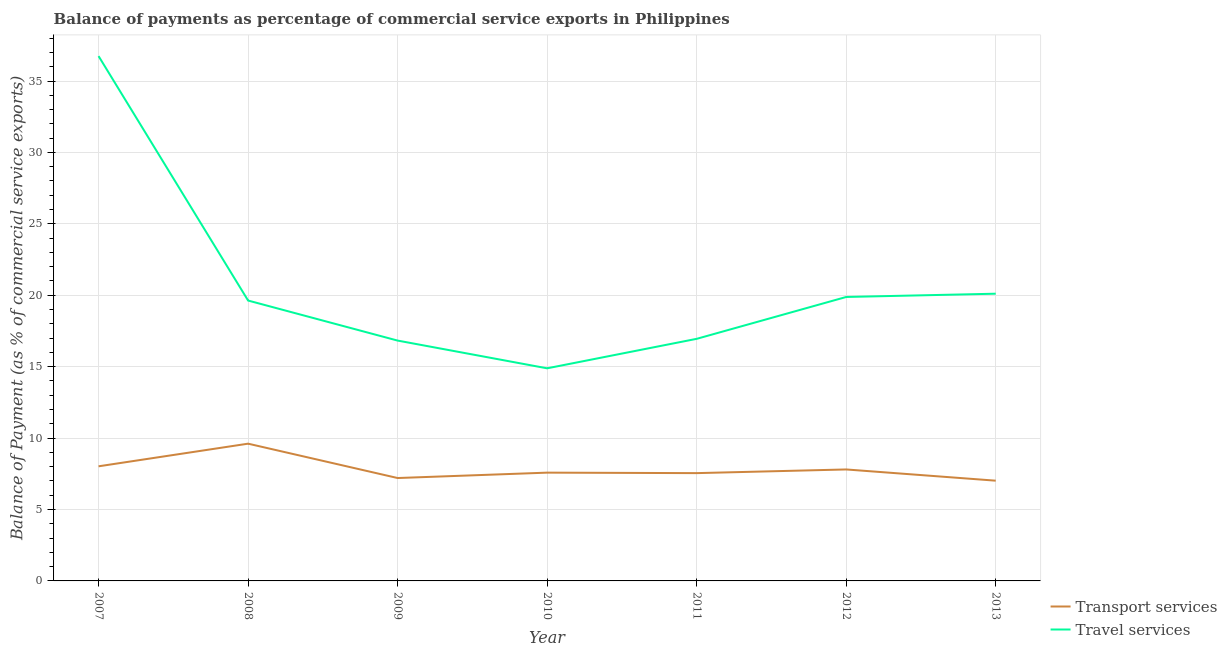How many different coloured lines are there?
Provide a short and direct response. 2. Is the number of lines equal to the number of legend labels?
Ensure brevity in your answer.  Yes. What is the balance of payments of transport services in 2011?
Make the answer very short. 7.55. Across all years, what is the maximum balance of payments of travel services?
Your response must be concise. 36.74. Across all years, what is the minimum balance of payments of travel services?
Give a very brief answer. 14.88. In which year was the balance of payments of transport services maximum?
Provide a short and direct response. 2008. What is the total balance of payments of transport services in the graph?
Your response must be concise. 54.79. What is the difference between the balance of payments of transport services in 2008 and that in 2011?
Provide a short and direct response. 2.06. What is the difference between the balance of payments of transport services in 2012 and the balance of payments of travel services in 2010?
Provide a succinct answer. -7.08. What is the average balance of payments of transport services per year?
Provide a short and direct response. 7.83. In the year 2010, what is the difference between the balance of payments of travel services and balance of payments of transport services?
Make the answer very short. 7.3. In how many years, is the balance of payments of travel services greater than 6 %?
Your response must be concise. 7. What is the ratio of the balance of payments of travel services in 2007 to that in 2010?
Offer a terse response. 2.47. Is the balance of payments of travel services in 2007 less than that in 2012?
Ensure brevity in your answer.  No. Is the difference between the balance of payments of transport services in 2009 and 2010 greater than the difference between the balance of payments of travel services in 2009 and 2010?
Your answer should be very brief. No. What is the difference between the highest and the second highest balance of payments of travel services?
Ensure brevity in your answer.  16.63. What is the difference between the highest and the lowest balance of payments of travel services?
Make the answer very short. 21.86. Is the balance of payments of travel services strictly less than the balance of payments of transport services over the years?
Provide a short and direct response. No. How many lines are there?
Your response must be concise. 2. How many years are there in the graph?
Make the answer very short. 7. Does the graph contain any zero values?
Keep it short and to the point. No. How are the legend labels stacked?
Make the answer very short. Vertical. What is the title of the graph?
Make the answer very short. Balance of payments as percentage of commercial service exports in Philippines. Does "Urban Population" appear as one of the legend labels in the graph?
Make the answer very short. No. What is the label or title of the Y-axis?
Make the answer very short. Balance of Payment (as % of commercial service exports). What is the Balance of Payment (as % of commercial service exports) in Transport services in 2007?
Offer a terse response. 8.02. What is the Balance of Payment (as % of commercial service exports) in Travel services in 2007?
Provide a short and direct response. 36.74. What is the Balance of Payment (as % of commercial service exports) in Transport services in 2008?
Keep it short and to the point. 9.61. What is the Balance of Payment (as % of commercial service exports) in Travel services in 2008?
Your response must be concise. 19.63. What is the Balance of Payment (as % of commercial service exports) of Transport services in 2009?
Provide a short and direct response. 7.2. What is the Balance of Payment (as % of commercial service exports) in Travel services in 2009?
Your answer should be very brief. 16.83. What is the Balance of Payment (as % of commercial service exports) of Transport services in 2010?
Your answer should be very brief. 7.58. What is the Balance of Payment (as % of commercial service exports) in Travel services in 2010?
Provide a short and direct response. 14.88. What is the Balance of Payment (as % of commercial service exports) of Transport services in 2011?
Offer a very short reply. 7.55. What is the Balance of Payment (as % of commercial service exports) in Travel services in 2011?
Provide a succinct answer. 16.95. What is the Balance of Payment (as % of commercial service exports) of Transport services in 2012?
Make the answer very short. 7.8. What is the Balance of Payment (as % of commercial service exports) in Travel services in 2012?
Provide a short and direct response. 19.88. What is the Balance of Payment (as % of commercial service exports) of Transport services in 2013?
Make the answer very short. 7.02. What is the Balance of Payment (as % of commercial service exports) in Travel services in 2013?
Your response must be concise. 20.11. Across all years, what is the maximum Balance of Payment (as % of commercial service exports) in Transport services?
Your response must be concise. 9.61. Across all years, what is the maximum Balance of Payment (as % of commercial service exports) of Travel services?
Give a very brief answer. 36.74. Across all years, what is the minimum Balance of Payment (as % of commercial service exports) in Transport services?
Offer a very short reply. 7.02. Across all years, what is the minimum Balance of Payment (as % of commercial service exports) in Travel services?
Ensure brevity in your answer.  14.88. What is the total Balance of Payment (as % of commercial service exports) in Transport services in the graph?
Offer a very short reply. 54.79. What is the total Balance of Payment (as % of commercial service exports) in Travel services in the graph?
Your answer should be very brief. 145.02. What is the difference between the Balance of Payment (as % of commercial service exports) in Transport services in 2007 and that in 2008?
Keep it short and to the point. -1.58. What is the difference between the Balance of Payment (as % of commercial service exports) of Travel services in 2007 and that in 2008?
Provide a short and direct response. 17.11. What is the difference between the Balance of Payment (as % of commercial service exports) in Transport services in 2007 and that in 2009?
Offer a very short reply. 0.82. What is the difference between the Balance of Payment (as % of commercial service exports) of Travel services in 2007 and that in 2009?
Give a very brief answer. 19.92. What is the difference between the Balance of Payment (as % of commercial service exports) in Transport services in 2007 and that in 2010?
Provide a succinct answer. 0.44. What is the difference between the Balance of Payment (as % of commercial service exports) of Travel services in 2007 and that in 2010?
Offer a very short reply. 21.86. What is the difference between the Balance of Payment (as % of commercial service exports) in Transport services in 2007 and that in 2011?
Keep it short and to the point. 0.48. What is the difference between the Balance of Payment (as % of commercial service exports) of Travel services in 2007 and that in 2011?
Offer a terse response. 19.79. What is the difference between the Balance of Payment (as % of commercial service exports) in Transport services in 2007 and that in 2012?
Keep it short and to the point. 0.22. What is the difference between the Balance of Payment (as % of commercial service exports) of Travel services in 2007 and that in 2012?
Ensure brevity in your answer.  16.86. What is the difference between the Balance of Payment (as % of commercial service exports) of Transport services in 2007 and that in 2013?
Offer a terse response. 1.01. What is the difference between the Balance of Payment (as % of commercial service exports) of Travel services in 2007 and that in 2013?
Your answer should be compact. 16.63. What is the difference between the Balance of Payment (as % of commercial service exports) of Transport services in 2008 and that in 2009?
Your answer should be very brief. 2.41. What is the difference between the Balance of Payment (as % of commercial service exports) in Travel services in 2008 and that in 2009?
Make the answer very short. 2.8. What is the difference between the Balance of Payment (as % of commercial service exports) of Transport services in 2008 and that in 2010?
Make the answer very short. 2.03. What is the difference between the Balance of Payment (as % of commercial service exports) of Travel services in 2008 and that in 2010?
Keep it short and to the point. 4.74. What is the difference between the Balance of Payment (as % of commercial service exports) of Transport services in 2008 and that in 2011?
Keep it short and to the point. 2.06. What is the difference between the Balance of Payment (as % of commercial service exports) in Travel services in 2008 and that in 2011?
Your answer should be compact. 2.68. What is the difference between the Balance of Payment (as % of commercial service exports) of Transport services in 2008 and that in 2012?
Your response must be concise. 1.81. What is the difference between the Balance of Payment (as % of commercial service exports) in Travel services in 2008 and that in 2012?
Your response must be concise. -0.25. What is the difference between the Balance of Payment (as % of commercial service exports) of Transport services in 2008 and that in 2013?
Your answer should be compact. 2.59. What is the difference between the Balance of Payment (as % of commercial service exports) in Travel services in 2008 and that in 2013?
Provide a succinct answer. -0.48. What is the difference between the Balance of Payment (as % of commercial service exports) of Transport services in 2009 and that in 2010?
Provide a succinct answer. -0.38. What is the difference between the Balance of Payment (as % of commercial service exports) of Travel services in 2009 and that in 2010?
Give a very brief answer. 1.94. What is the difference between the Balance of Payment (as % of commercial service exports) in Transport services in 2009 and that in 2011?
Keep it short and to the point. -0.34. What is the difference between the Balance of Payment (as % of commercial service exports) in Travel services in 2009 and that in 2011?
Keep it short and to the point. -0.12. What is the difference between the Balance of Payment (as % of commercial service exports) in Transport services in 2009 and that in 2012?
Give a very brief answer. -0.6. What is the difference between the Balance of Payment (as % of commercial service exports) in Travel services in 2009 and that in 2012?
Keep it short and to the point. -3.05. What is the difference between the Balance of Payment (as % of commercial service exports) in Transport services in 2009 and that in 2013?
Your response must be concise. 0.19. What is the difference between the Balance of Payment (as % of commercial service exports) of Travel services in 2009 and that in 2013?
Your answer should be very brief. -3.28. What is the difference between the Balance of Payment (as % of commercial service exports) of Transport services in 2010 and that in 2011?
Your response must be concise. 0.03. What is the difference between the Balance of Payment (as % of commercial service exports) in Travel services in 2010 and that in 2011?
Give a very brief answer. -2.06. What is the difference between the Balance of Payment (as % of commercial service exports) of Transport services in 2010 and that in 2012?
Keep it short and to the point. -0.22. What is the difference between the Balance of Payment (as % of commercial service exports) of Travel services in 2010 and that in 2012?
Your response must be concise. -4.99. What is the difference between the Balance of Payment (as % of commercial service exports) in Transport services in 2010 and that in 2013?
Your answer should be very brief. 0.56. What is the difference between the Balance of Payment (as % of commercial service exports) of Travel services in 2010 and that in 2013?
Provide a succinct answer. -5.22. What is the difference between the Balance of Payment (as % of commercial service exports) in Transport services in 2011 and that in 2012?
Give a very brief answer. -0.26. What is the difference between the Balance of Payment (as % of commercial service exports) of Travel services in 2011 and that in 2012?
Your response must be concise. -2.93. What is the difference between the Balance of Payment (as % of commercial service exports) of Transport services in 2011 and that in 2013?
Offer a very short reply. 0.53. What is the difference between the Balance of Payment (as % of commercial service exports) of Travel services in 2011 and that in 2013?
Your answer should be very brief. -3.16. What is the difference between the Balance of Payment (as % of commercial service exports) of Transport services in 2012 and that in 2013?
Your answer should be very brief. 0.79. What is the difference between the Balance of Payment (as % of commercial service exports) in Travel services in 2012 and that in 2013?
Your response must be concise. -0.23. What is the difference between the Balance of Payment (as % of commercial service exports) in Transport services in 2007 and the Balance of Payment (as % of commercial service exports) in Travel services in 2008?
Provide a short and direct response. -11.61. What is the difference between the Balance of Payment (as % of commercial service exports) in Transport services in 2007 and the Balance of Payment (as % of commercial service exports) in Travel services in 2009?
Your answer should be compact. -8.8. What is the difference between the Balance of Payment (as % of commercial service exports) in Transport services in 2007 and the Balance of Payment (as % of commercial service exports) in Travel services in 2010?
Provide a succinct answer. -6.86. What is the difference between the Balance of Payment (as % of commercial service exports) of Transport services in 2007 and the Balance of Payment (as % of commercial service exports) of Travel services in 2011?
Give a very brief answer. -8.92. What is the difference between the Balance of Payment (as % of commercial service exports) of Transport services in 2007 and the Balance of Payment (as % of commercial service exports) of Travel services in 2012?
Keep it short and to the point. -11.86. What is the difference between the Balance of Payment (as % of commercial service exports) in Transport services in 2007 and the Balance of Payment (as % of commercial service exports) in Travel services in 2013?
Your answer should be very brief. -12.08. What is the difference between the Balance of Payment (as % of commercial service exports) of Transport services in 2008 and the Balance of Payment (as % of commercial service exports) of Travel services in 2009?
Give a very brief answer. -7.22. What is the difference between the Balance of Payment (as % of commercial service exports) of Transport services in 2008 and the Balance of Payment (as % of commercial service exports) of Travel services in 2010?
Your response must be concise. -5.28. What is the difference between the Balance of Payment (as % of commercial service exports) of Transport services in 2008 and the Balance of Payment (as % of commercial service exports) of Travel services in 2011?
Make the answer very short. -7.34. What is the difference between the Balance of Payment (as % of commercial service exports) of Transport services in 2008 and the Balance of Payment (as % of commercial service exports) of Travel services in 2012?
Your answer should be compact. -10.27. What is the difference between the Balance of Payment (as % of commercial service exports) in Transport services in 2008 and the Balance of Payment (as % of commercial service exports) in Travel services in 2013?
Your answer should be compact. -10.5. What is the difference between the Balance of Payment (as % of commercial service exports) in Transport services in 2009 and the Balance of Payment (as % of commercial service exports) in Travel services in 2010?
Your response must be concise. -7.68. What is the difference between the Balance of Payment (as % of commercial service exports) in Transport services in 2009 and the Balance of Payment (as % of commercial service exports) in Travel services in 2011?
Ensure brevity in your answer.  -9.75. What is the difference between the Balance of Payment (as % of commercial service exports) in Transport services in 2009 and the Balance of Payment (as % of commercial service exports) in Travel services in 2012?
Keep it short and to the point. -12.68. What is the difference between the Balance of Payment (as % of commercial service exports) in Transport services in 2009 and the Balance of Payment (as % of commercial service exports) in Travel services in 2013?
Provide a succinct answer. -12.91. What is the difference between the Balance of Payment (as % of commercial service exports) of Transport services in 2010 and the Balance of Payment (as % of commercial service exports) of Travel services in 2011?
Your response must be concise. -9.37. What is the difference between the Balance of Payment (as % of commercial service exports) of Transport services in 2010 and the Balance of Payment (as % of commercial service exports) of Travel services in 2012?
Provide a short and direct response. -12.3. What is the difference between the Balance of Payment (as % of commercial service exports) of Transport services in 2010 and the Balance of Payment (as % of commercial service exports) of Travel services in 2013?
Offer a very short reply. -12.53. What is the difference between the Balance of Payment (as % of commercial service exports) in Transport services in 2011 and the Balance of Payment (as % of commercial service exports) in Travel services in 2012?
Ensure brevity in your answer.  -12.33. What is the difference between the Balance of Payment (as % of commercial service exports) in Transport services in 2011 and the Balance of Payment (as % of commercial service exports) in Travel services in 2013?
Your response must be concise. -12.56. What is the difference between the Balance of Payment (as % of commercial service exports) in Transport services in 2012 and the Balance of Payment (as % of commercial service exports) in Travel services in 2013?
Offer a terse response. -12.31. What is the average Balance of Payment (as % of commercial service exports) in Transport services per year?
Offer a terse response. 7.83. What is the average Balance of Payment (as % of commercial service exports) in Travel services per year?
Make the answer very short. 20.72. In the year 2007, what is the difference between the Balance of Payment (as % of commercial service exports) in Transport services and Balance of Payment (as % of commercial service exports) in Travel services?
Provide a succinct answer. -28.72. In the year 2008, what is the difference between the Balance of Payment (as % of commercial service exports) of Transport services and Balance of Payment (as % of commercial service exports) of Travel services?
Ensure brevity in your answer.  -10.02. In the year 2009, what is the difference between the Balance of Payment (as % of commercial service exports) of Transport services and Balance of Payment (as % of commercial service exports) of Travel services?
Your answer should be very brief. -9.62. In the year 2010, what is the difference between the Balance of Payment (as % of commercial service exports) in Transport services and Balance of Payment (as % of commercial service exports) in Travel services?
Your response must be concise. -7.3. In the year 2011, what is the difference between the Balance of Payment (as % of commercial service exports) of Transport services and Balance of Payment (as % of commercial service exports) of Travel services?
Your answer should be very brief. -9.4. In the year 2012, what is the difference between the Balance of Payment (as % of commercial service exports) in Transport services and Balance of Payment (as % of commercial service exports) in Travel services?
Provide a short and direct response. -12.08. In the year 2013, what is the difference between the Balance of Payment (as % of commercial service exports) in Transport services and Balance of Payment (as % of commercial service exports) in Travel services?
Your response must be concise. -13.09. What is the ratio of the Balance of Payment (as % of commercial service exports) in Transport services in 2007 to that in 2008?
Your answer should be compact. 0.84. What is the ratio of the Balance of Payment (as % of commercial service exports) in Travel services in 2007 to that in 2008?
Ensure brevity in your answer.  1.87. What is the ratio of the Balance of Payment (as % of commercial service exports) in Transport services in 2007 to that in 2009?
Ensure brevity in your answer.  1.11. What is the ratio of the Balance of Payment (as % of commercial service exports) in Travel services in 2007 to that in 2009?
Give a very brief answer. 2.18. What is the ratio of the Balance of Payment (as % of commercial service exports) of Transport services in 2007 to that in 2010?
Your answer should be very brief. 1.06. What is the ratio of the Balance of Payment (as % of commercial service exports) in Travel services in 2007 to that in 2010?
Make the answer very short. 2.47. What is the ratio of the Balance of Payment (as % of commercial service exports) in Transport services in 2007 to that in 2011?
Offer a very short reply. 1.06. What is the ratio of the Balance of Payment (as % of commercial service exports) in Travel services in 2007 to that in 2011?
Offer a terse response. 2.17. What is the ratio of the Balance of Payment (as % of commercial service exports) in Transport services in 2007 to that in 2012?
Make the answer very short. 1.03. What is the ratio of the Balance of Payment (as % of commercial service exports) of Travel services in 2007 to that in 2012?
Ensure brevity in your answer.  1.85. What is the ratio of the Balance of Payment (as % of commercial service exports) in Transport services in 2007 to that in 2013?
Provide a succinct answer. 1.14. What is the ratio of the Balance of Payment (as % of commercial service exports) in Travel services in 2007 to that in 2013?
Ensure brevity in your answer.  1.83. What is the ratio of the Balance of Payment (as % of commercial service exports) in Transport services in 2008 to that in 2009?
Your response must be concise. 1.33. What is the ratio of the Balance of Payment (as % of commercial service exports) in Travel services in 2008 to that in 2009?
Your answer should be compact. 1.17. What is the ratio of the Balance of Payment (as % of commercial service exports) in Transport services in 2008 to that in 2010?
Your response must be concise. 1.27. What is the ratio of the Balance of Payment (as % of commercial service exports) in Travel services in 2008 to that in 2010?
Keep it short and to the point. 1.32. What is the ratio of the Balance of Payment (as % of commercial service exports) in Transport services in 2008 to that in 2011?
Your response must be concise. 1.27. What is the ratio of the Balance of Payment (as % of commercial service exports) of Travel services in 2008 to that in 2011?
Provide a short and direct response. 1.16. What is the ratio of the Balance of Payment (as % of commercial service exports) in Transport services in 2008 to that in 2012?
Your answer should be compact. 1.23. What is the ratio of the Balance of Payment (as % of commercial service exports) of Travel services in 2008 to that in 2012?
Your answer should be compact. 0.99. What is the ratio of the Balance of Payment (as % of commercial service exports) of Transport services in 2008 to that in 2013?
Your answer should be compact. 1.37. What is the ratio of the Balance of Payment (as % of commercial service exports) of Travel services in 2008 to that in 2013?
Provide a short and direct response. 0.98. What is the ratio of the Balance of Payment (as % of commercial service exports) of Transport services in 2009 to that in 2010?
Keep it short and to the point. 0.95. What is the ratio of the Balance of Payment (as % of commercial service exports) in Travel services in 2009 to that in 2010?
Your answer should be compact. 1.13. What is the ratio of the Balance of Payment (as % of commercial service exports) of Transport services in 2009 to that in 2011?
Your response must be concise. 0.95. What is the ratio of the Balance of Payment (as % of commercial service exports) of Travel services in 2009 to that in 2012?
Your answer should be very brief. 0.85. What is the ratio of the Balance of Payment (as % of commercial service exports) in Transport services in 2009 to that in 2013?
Offer a terse response. 1.03. What is the ratio of the Balance of Payment (as % of commercial service exports) of Travel services in 2009 to that in 2013?
Keep it short and to the point. 0.84. What is the ratio of the Balance of Payment (as % of commercial service exports) in Transport services in 2010 to that in 2011?
Provide a short and direct response. 1. What is the ratio of the Balance of Payment (as % of commercial service exports) in Travel services in 2010 to that in 2011?
Offer a terse response. 0.88. What is the ratio of the Balance of Payment (as % of commercial service exports) in Transport services in 2010 to that in 2012?
Make the answer very short. 0.97. What is the ratio of the Balance of Payment (as % of commercial service exports) in Travel services in 2010 to that in 2012?
Your response must be concise. 0.75. What is the ratio of the Balance of Payment (as % of commercial service exports) in Transport services in 2010 to that in 2013?
Give a very brief answer. 1.08. What is the ratio of the Balance of Payment (as % of commercial service exports) in Travel services in 2010 to that in 2013?
Provide a short and direct response. 0.74. What is the ratio of the Balance of Payment (as % of commercial service exports) of Transport services in 2011 to that in 2012?
Your response must be concise. 0.97. What is the ratio of the Balance of Payment (as % of commercial service exports) in Travel services in 2011 to that in 2012?
Make the answer very short. 0.85. What is the ratio of the Balance of Payment (as % of commercial service exports) of Transport services in 2011 to that in 2013?
Provide a succinct answer. 1.08. What is the ratio of the Balance of Payment (as % of commercial service exports) in Travel services in 2011 to that in 2013?
Offer a very short reply. 0.84. What is the ratio of the Balance of Payment (as % of commercial service exports) of Transport services in 2012 to that in 2013?
Keep it short and to the point. 1.11. What is the difference between the highest and the second highest Balance of Payment (as % of commercial service exports) of Transport services?
Ensure brevity in your answer.  1.58. What is the difference between the highest and the second highest Balance of Payment (as % of commercial service exports) of Travel services?
Provide a succinct answer. 16.63. What is the difference between the highest and the lowest Balance of Payment (as % of commercial service exports) of Transport services?
Provide a short and direct response. 2.59. What is the difference between the highest and the lowest Balance of Payment (as % of commercial service exports) of Travel services?
Provide a short and direct response. 21.86. 